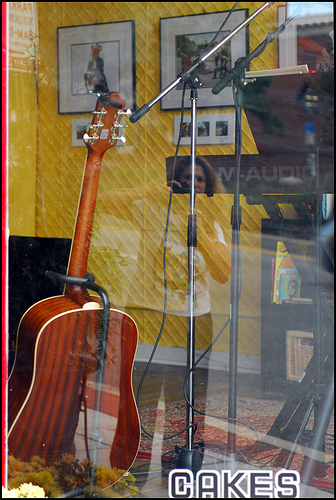<image>
Can you confirm if the guitar is in front of the glass? Yes. The guitar is positioned in front of the glass, appearing closer to the camera viewpoint. 